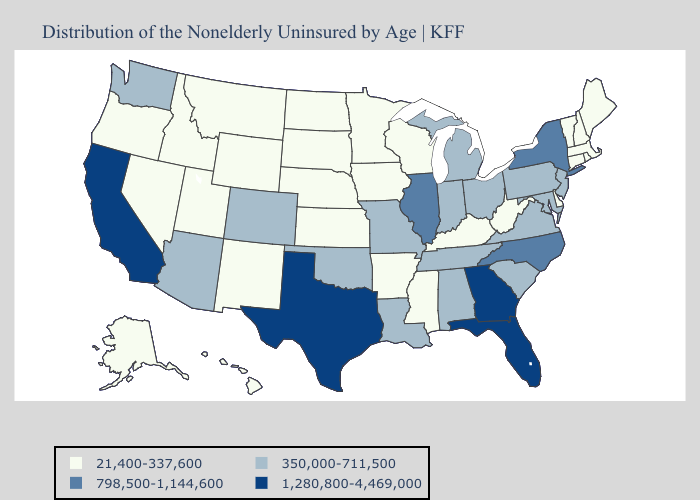What is the lowest value in the USA?
Short answer required. 21,400-337,600. Name the states that have a value in the range 1,280,800-4,469,000?
Keep it brief. California, Florida, Georgia, Texas. Does New Jersey have the lowest value in the Northeast?
Be succinct. No. Name the states that have a value in the range 798,500-1,144,600?
Give a very brief answer. Illinois, New York, North Carolina. Does the first symbol in the legend represent the smallest category?
Answer briefly. Yes. Which states have the lowest value in the MidWest?
Answer briefly. Iowa, Kansas, Minnesota, Nebraska, North Dakota, South Dakota, Wisconsin. Name the states that have a value in the range 1,280,800-4,469,000?
Write a very short answer. California, Florida, Georgia, Texas. Is the legend a continuous bar?
Answer briefly. No. Name the states that have a value in the range 1,280,800-4,469,000?
Short answer required. California, Florida, Georgia, Texas. What is the lowest value in the South?
Keep it brief. 21,400-337,600. What is the value of Kansas?
Be succinct. 21,400-337,600. What is the value of Texas?
Be succinct. 1,280,800-4,469,000. Does the map have missing data?
Give a very brief answer. No. What is the lowest value in the USA?
Write a very short answer. 21,400-337,600. Does the first symbol in the legend represent the smallest category?
Give a very brief answer. Yes. 